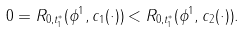<formula> <loc_0><loc_0><loc_500><loc_500>0 = R _ { 0 , t ^ { * } _ { 1 } } ( \phi ^ { 1 } , c _ { 1 } ( \cdot ) ) < R _ { 0 , t ^ { * } _ { 1 } } ( \phi ^ { 1 } , c _ { 2 } ( \cdot ) ) .</formula> 